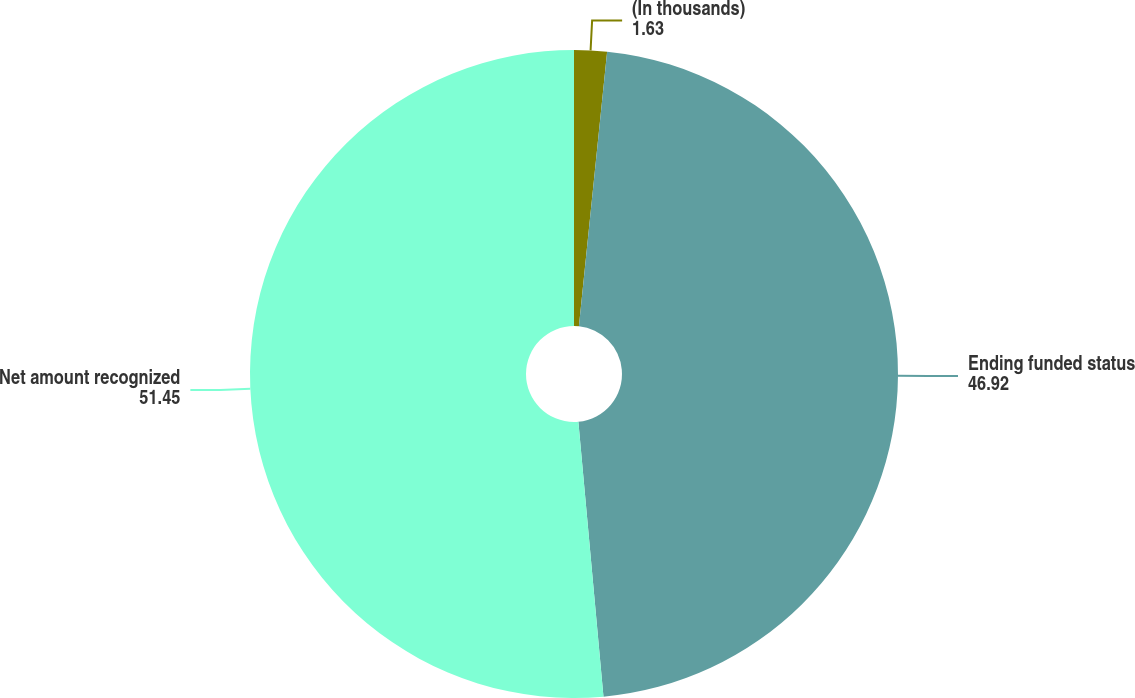<chart> <loc_0><loc_0><loc_500><loc_500><pie_chart><fcel>(In thousands)<fcel>Ending funded status<fcel>Net amount recognized<nl><fcel>1.63%<fcel>46.92%<fcel>51.45%<nl></chart> 